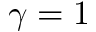Convert formula to latex. <formula><loc_0><loc_0><loc_500><loc_500>\gamma = 1</formula> 